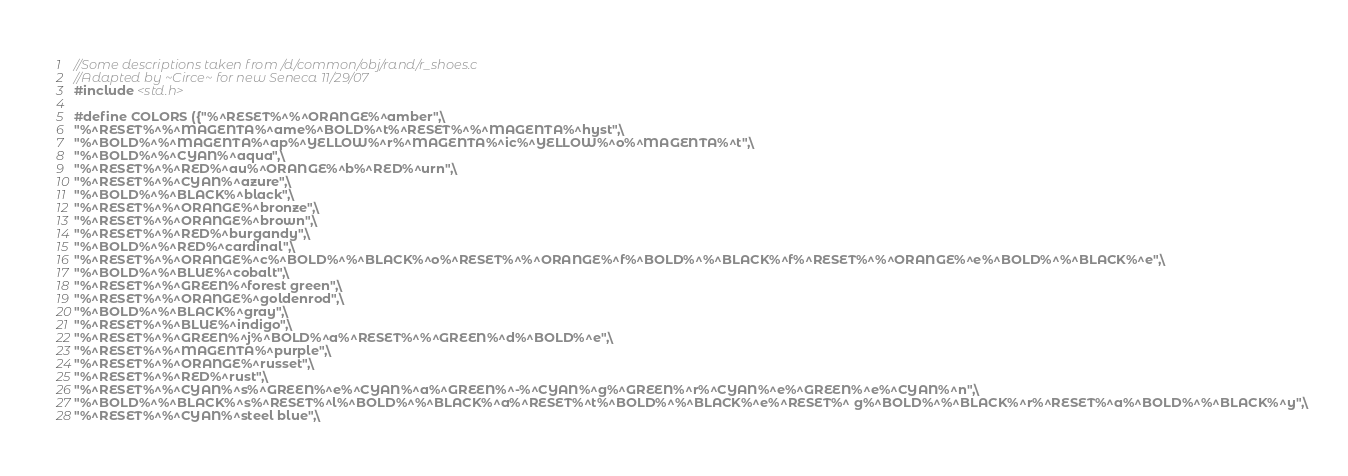Convert code to text. <code><loc_0><loc_0><loc_500><loc_500><_C_>//Some descriptions taken from /d/common/obj/rand/r_shoes.c
//Adapted by ~Circe~ for new Seneca 11/29/07
#include <std.h>

#define COLORS ({"%^RESET%^%^ORANGE%^amber",\
"%^RESET%^%^MAGENTA%^ame%^BOLD%^t%^RESET%^%^MAGENTA%^hyst",\
"%^BOLD%^%^MAGENTA%^ap%^YELLOW%^r%^MAGENTA%^ic%^YELLOW%^o%^MAGENTA%^t",\
"%^BOLD%^%^CYAN%^aqua",\
"%^RESET%^%^RED%^au%^ORANGE%^b%^RED%^urn",\
"%^RESET%^%^CYAN%^azure",\
"%^BOLD%^%^BLACK%^black",\
"%^RESET%^%^ORANGE%^bronze",\
"%^RESET%^%^ORANGE%^brown",\
"%^RESET%^%^RED%^burgandy",\
"%^BOLD%^%^RED%^cardinal",\
"%^RESET%^%^ORANGE%^c%^BOLD%^%^BLACK%^o%^RESET%^%^ORANGE%^f%^BOLD%^%^BLACK%^f%^RESET%^%^ORANGE%^e%^BOLD%^%^BLACK%^e",\
"%^BOLD%^%^BLUE%^cobalt",\
"%^RESET%^%^GREEN%^forest green",\
"%^RESET%^%^ORANGE%^goldenrod",\
"%^BOLD%^%^BLACK%^gray",\
"%^RESET%^%^BLUE%^indigo",\
"%^RESET%^%^GREEN%^j%^BOLD%^a%^RESET%^%^GREEN%^d%^BOLD%^e",\
"%^RESET%^%^MAGENTA%^purple",\
"%^RESET%^%^ORANGE%^russet",\
"%^RESET%^%^RED%^rust",\
"%^RESET%^%^CYAN%^s%^GREEN%^e%^CYAN%^a%^GREEN%^-%^CYAN%^g%^GREEN%^r%^CYAN%^e%^GREEN%^e%^CYAN%^n",\
"%^BOLD%^%^BLACK%^s%^RESET%^l%^BOLD%^%^BLACK%^a%^RESET%^t%^BOLD%^%^BLACK%^e%^RESET%^ g%^BOLD%^%^BLACK%^r%^RESET%^a%^BOLD%^%^BLACK%^y",\
"%^RESET%^%^CYAN%^steel blue",\</code> 